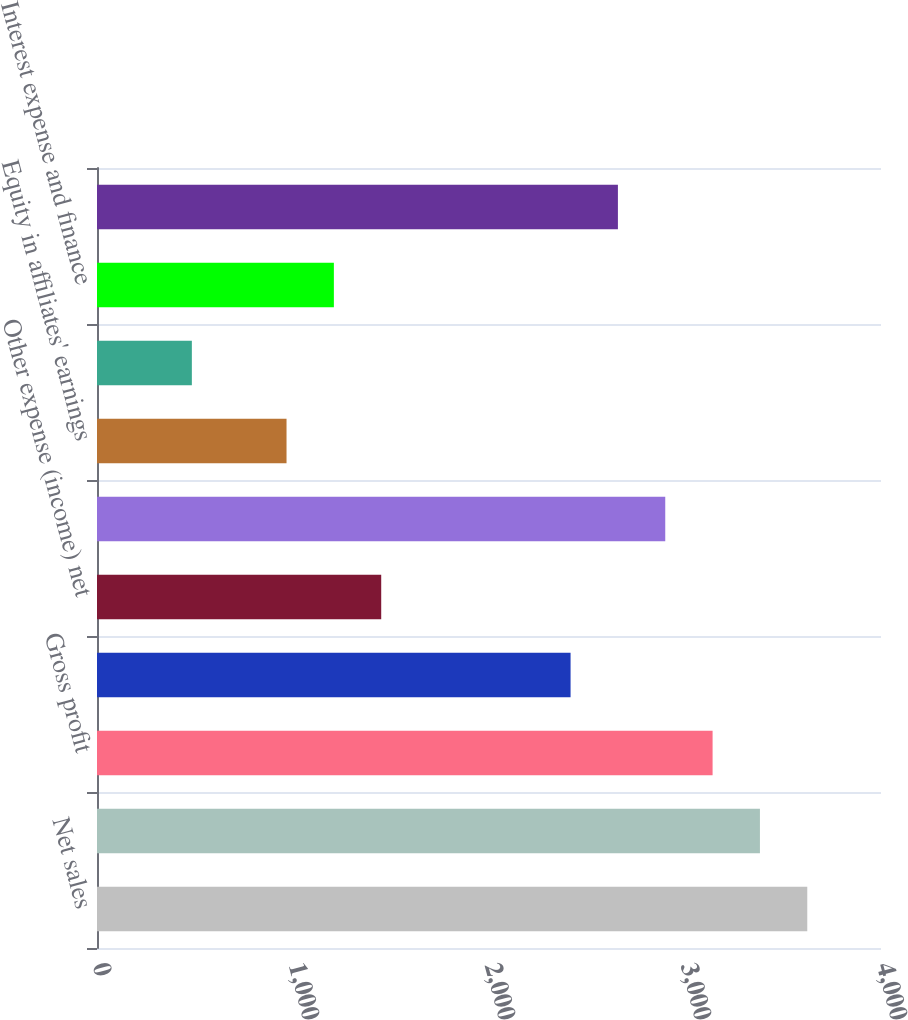Convert chart to OTSL. <chart><loc_0><loc_0><loc_500><loc_500><bar_chart><fcel>Net sales<fcel>Cost of sales<fcel>Gross profit<fcel>Selling general and<fcel>Other expense (income) net<fcel>Operating income (loss)<fcel>Equity in affiliates' earnings<fcel>Interest income<fcel>Interest expense and finance<fcel>Earnings (loss) before income<nl><fcel>3623.83<fcel>3382.3<fcel>3140.77<fcel>2416.18<fcel>1450.06<fcel>2899.24<fcel>967<fcel>483.94<fcel>1208.53<fcel>2657.71<nl></chart> 